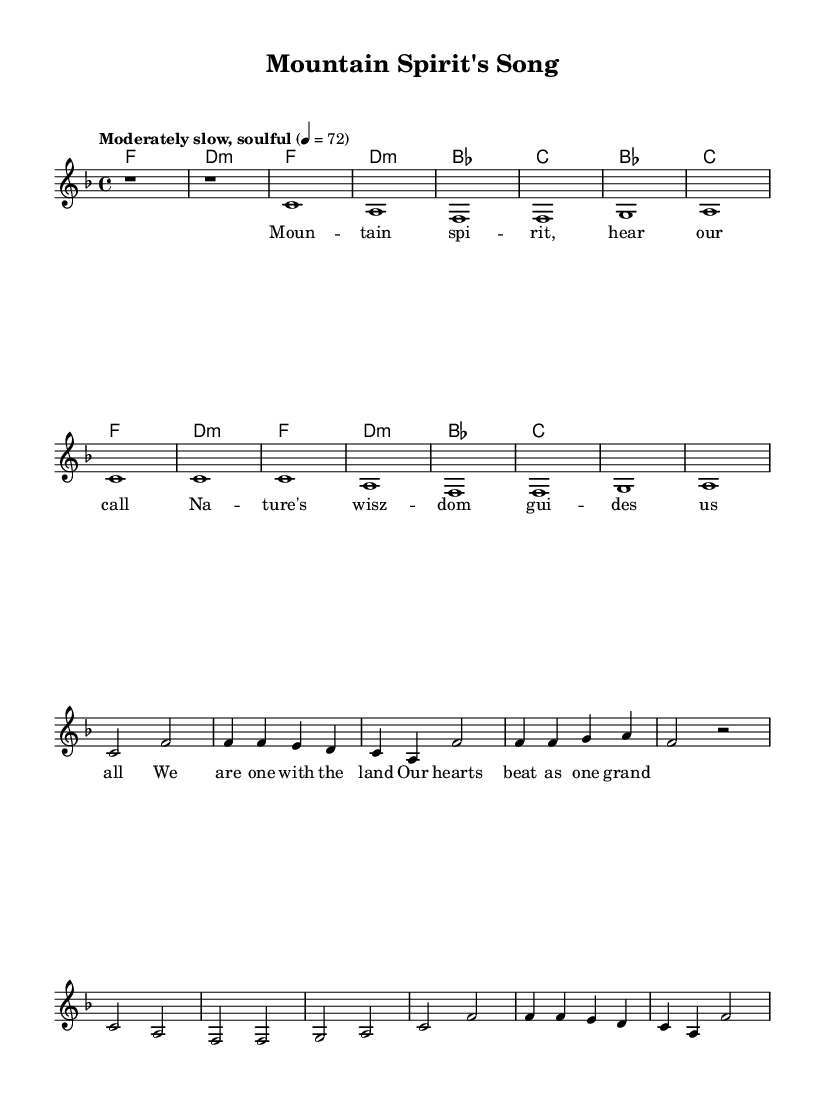What is the key signature of this music? The key signature is F major, which has one flat (B flat). This is indicated right after the clef at the beginning of the staff.
Answer: F major What is the time signature of the piece? The time signature is 4/4, which means there are four beats in each measure, and the quarter note receives one beat. This is shown at the beginning of the score next to the key signature.
Answer: 4/4 What is the tempo marking for the song? The tempo marking is "Moderately slow, soulful" followed by a metronome marking of 72. This describes the pace and feel of the music and is found at the beginning of the sheet music.
Answer: Moderately slow, soulful How many measures are in the first verse? The first verse consists of 4 measures, as seen in the melody section where there are 4 groups of notes leading up to the chorus. Each group represents a measure, and by counting them, we find the total.
Answer: 4 What is the first line of lyrics for the song? The first line of lyrics is "Mountain spirit, hear our call". This can be found in the lyric section below the melody, specifically the first phrase of the first verse.
Answer: Mountain spirit, hear our call What key do the chorus and verse chords begin on? Both the chorus and verse chords begin on B flat major, which is the first chord in their respective sections. This can be observed in the harmony section where B flat appears first when listing the chords.
Answer: B flat What is the primary theme conveyed in the song? The primary theme conveyed in the song is the connection between nature and the human spirit, emphasized through the lyrics and the use of musical elements that evoke emotional responses to the natural world. This theme is reflected in the overall lyrics and title.
Answer: Connection between nature and human spirit 